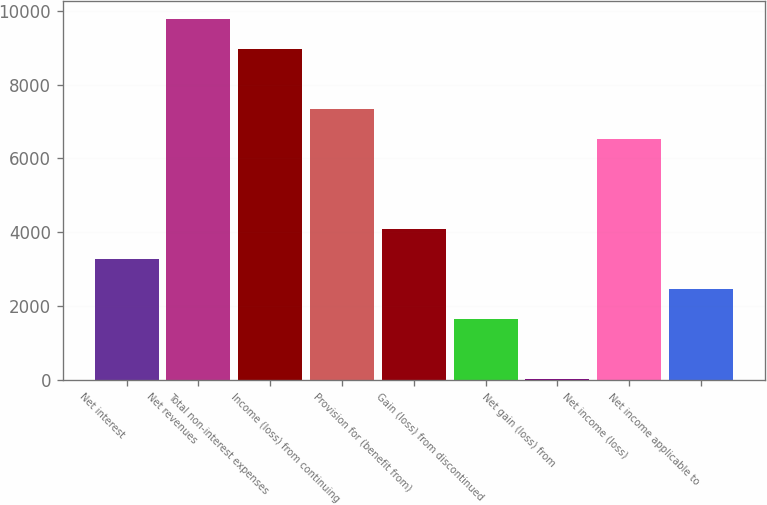Convert chart. <chart><loc_0><loc_0><loc_500><loc_500><bar_chart><fcel>Net interest<fcel>Net revenues<fcel>Total non-interest expenses<fcel>Income (loss) from continuing<fcel>Provision for (benefit from)<fcel>Gain (loss) from discontinued<fcel>Net gain (loss) from<fcel>Net income (loss)<fcel>Net income applicable to<nl><fcel>3273<fcel>9781<fcel>8967.5<fcel>7340.5<fcel>4086.5<fcel>1646<fcel>19<fcel>6527<fcel>2459.5<nl></chart> 